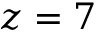<formula> <loc_0><loc_0><loc_500><loc_500>z = 7</formula> 